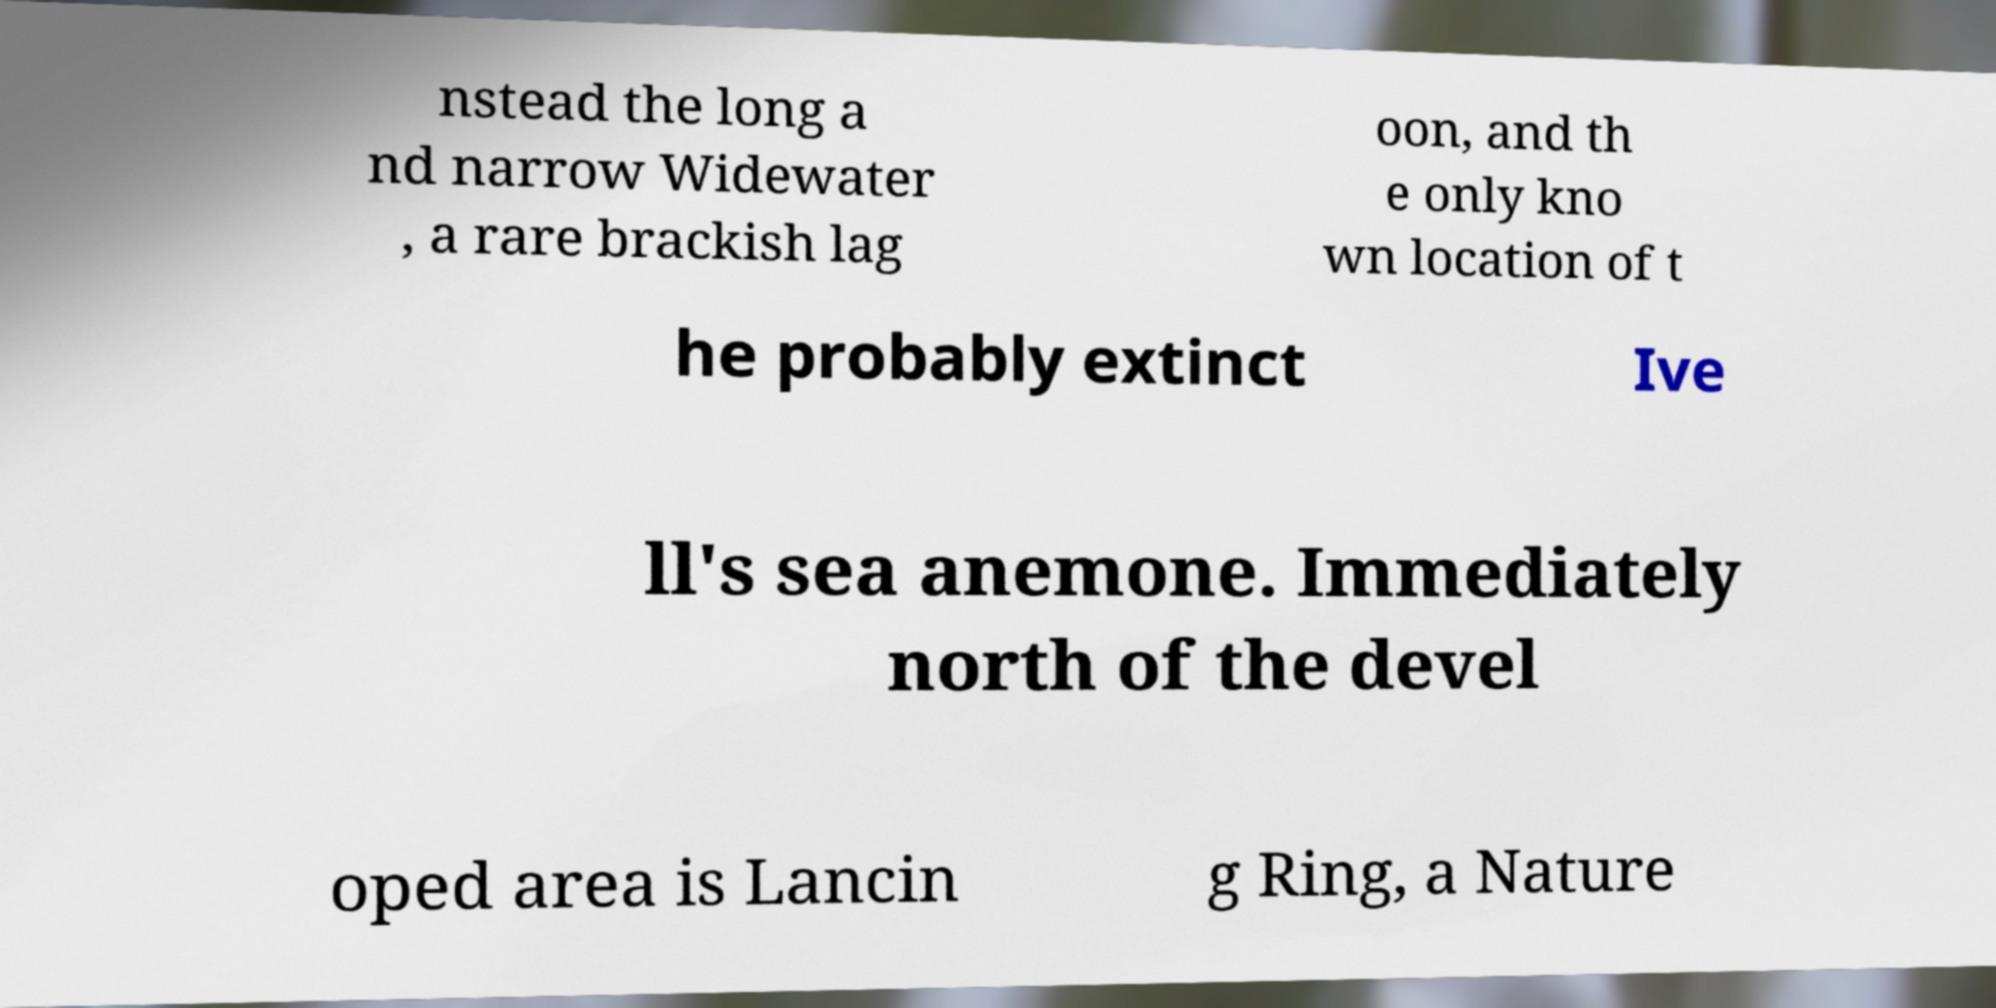There's text embedded in this image that I need extracted. Can you transcribe it verbatim? nstead the long a nd narrow Widewater , a rare brackish lag oon, and th e only kno wn location of t he probably extinct Ive ll's sea anemone. Immediately north of the devel oped area is Lancin g Ring, a Nature 